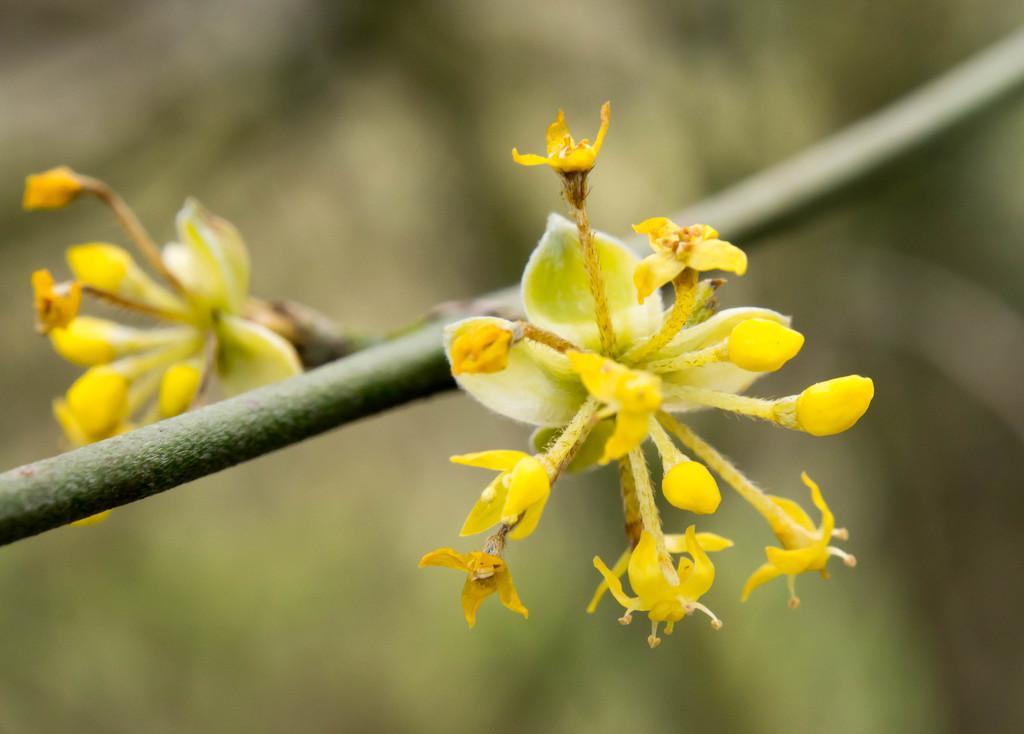Please provide a concise description of this image. In this picture we can see the flowers are present to the stem. In the background the image is blur. 